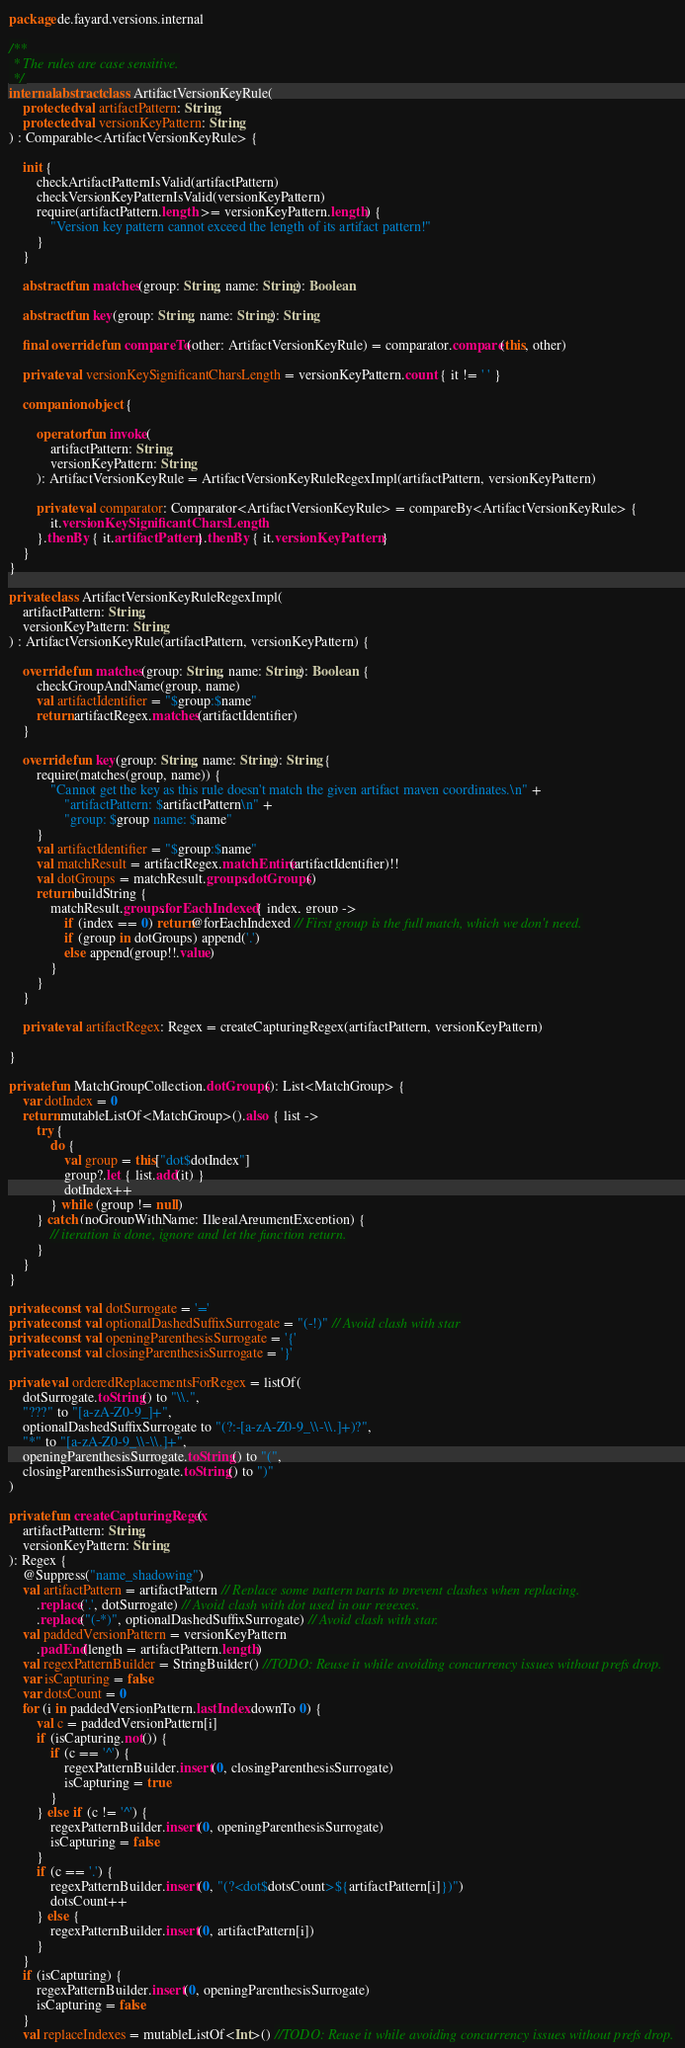Convert code to text. <code><loc_0><loc_0><loc_500><loc_500><_Kotlin_>package de.fayard.versions.internal

/**
 * The rules are case sensitive.
 */
internal abstract class ArtifactVersionKeyRule(
    protected val artifactPattern: String,
    protected val versionKeyPattern: String
) : Comparable<ArtifactVersionKeyRule> {

    init {
        checkArtifactPatternIsValid(artifactPattern)
        checkVersionKeyPatternIsValid(versionKeyPattern)
        require(artifactPattern.length >= versionKeyPattern.length) {
            "Version key pattern cannot exceed the length of its artifact pattern!"
        }
    }

    abstract fun matches(group: String, name: String): Boolean

    abstract fun key(group: String, name: String): String

    final override fun compareTo(other: ArtifactVersionKeyRule) = comparator.compare(this, other)

    private val versionKeySignificantCharsLength = versionKeyPattern.count { it != ' ' }

    companion object {

        operator fun invoke(
            artifactPattern: String,
            versionKeyPattern: String
        ): ArtifactVersionKeyRule = ArtifactVersionKeyRuleRegexImpl(artifactPattern, versionKeyPattern)

        private val comparator: Comparator<ArtifactVersionKeyRule> = compareBy<ArtifactVersionKeyRule> {
            it.versionKeySignificantCharsLength
        }.thenBy { it.artifactPattern }.thenBy { it.versionKeyPattern }
    }
}

private class ArtifactVersionKeyRuleRegexImpl(
    artifactPattern: String,
    versionKeyPattern: String
) : ArtifactVersionKeyRule(artifactPattern, versionKeyPattern) {

    override fun matches(group: String, name: String): Boolean {
        checkGroupAndName(group, name)
        val artifactIdentifier = "$group:$name"
        return artifactRegex.matches(artifactIdentifier)
    }

    override fun key(group: String, name: String): String {
        require(matches(group, name)) {
            "Cannot get the key as this rule doesn't match the given artifact maven coordinates.\n" +
                "artifactPattern: $artifactPattern\n" +
                "group: $group name: $name"
        }
        val artifactIdentifier = "$group:$name"
        val matchResult = artifactRegex.matchEntire(artifactIdentifier)!!
        val dotGroups = matchResult.groups.dotGroups()
        return buildString {
            matchResult.groups.forEachIndexed { index, group ->
                if (index == 0) return@forEachIndexed // First group is the full match, which we don't need.
                if (group in dotGroups) append('.')
                else append(group!!.value)
            }
        }
    }

    private val artifactRegex: Regex = createCapturingRegex(artifactPattern, versionKeyPattern)

}

private fun MatchGroupCollection.dotGroups(): List<MatchGroup> {
    var dotIndex = 0
    return mutableListOf<MatchGroup>().also { list ->
        try {
            do {
                val group = this["dot$dotIndex"]
                group?.let { list.add(it) }
                dotIndex++
            } while (group != null)
        } catch (noGroupWithName: IllegalArgumentException) {
            // iteration is done, ignore and let the function return.
        }
    }
}

private const val dotSurrogate = '='
private const val optionalDashedSuffixSurrogate = "(-!)" // Avoid clash with star
private const val openingParenthesisSurrogate = '{'
private const val closingParenthesisSurrogate = '}'

private val orderedReplacementsForRegex = listOf(
    dotSurrogate.toString() to "\\.",
    "???" to "[a-zA-Z0-9_]+",
    optionalDashedSuffixSurrogate to "(?:-[a-zA-Z0-9_\\-\\.]+)?",
    "*" to "[a-zA-Z0-9_\\-\\.]+",
    openingParenthesisSurrogate.toString() to "(",
    closingParenthesisSurrogate.toString() to ")"
)

private fun createCapturingRegex(
    artifactPattern: String,
    versionKeyPattern: String
): Regex {
    @Suppress("name_shadowing")
    val artifactPattern = artifactPattern // Replace some pattern parts to prevent clashes when replacing.
        .replace('.', dotSurrogate) // Avoid clash with dot used in our regexes.
        .replace("(-*)", optionalDashedSuffixSurrogate) // Avoid clash with star.
    val paddedVersionPattern = versionKeyPattern
        .padEnd(length = artifactPattern.length)
    val regexPatternBuilder = StringBuilder() //TODO: Reuse it while avoiding concurrency issues without prefs drop.
    var isCapturing = false
    var dotsCount = 0
    for (i in paddedVersionPattern.lastIndex downTo 0) {
        val c = paddedVersionPattern[i]
        if (isCapturing.not()) {
            if (c == '^') {
                regexPatternBuilder.insert(0, closingParenthesisSurrogate)
                isCapturing = true
            }
        } else if (c != '^') {
            regexPatternBuilder.insert(0, openingParenthesisSurrogate)
            isCapturing = false
        }
        if (c == '.') {
            regexPatternBuilder.insert(0, "(?<dot$dotsCount>${artifactPattern[i]})")
            dotsCount++
        } else {
            regexPatternBuilder.insert(0, artifactPattern[i])
        }
    }
    if (isCapturing) {
        regexPatternBuilder.insert(0, openingParenthesisSurrogate)
        isCapturing = false
    }
    val replaceIndexes = mutableListOf<Int>() //TODO: Reuse it while avoiding concurrency issues without prefs drop.</code> 